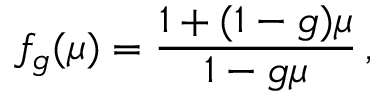<formula> <loc_0><loc_0><loc_500><loc_500>f _ { g } ( \mu ) = \frac { 1 + ( 1 - g ) \mu } { 1 - g \mu } \, ,</formula> 